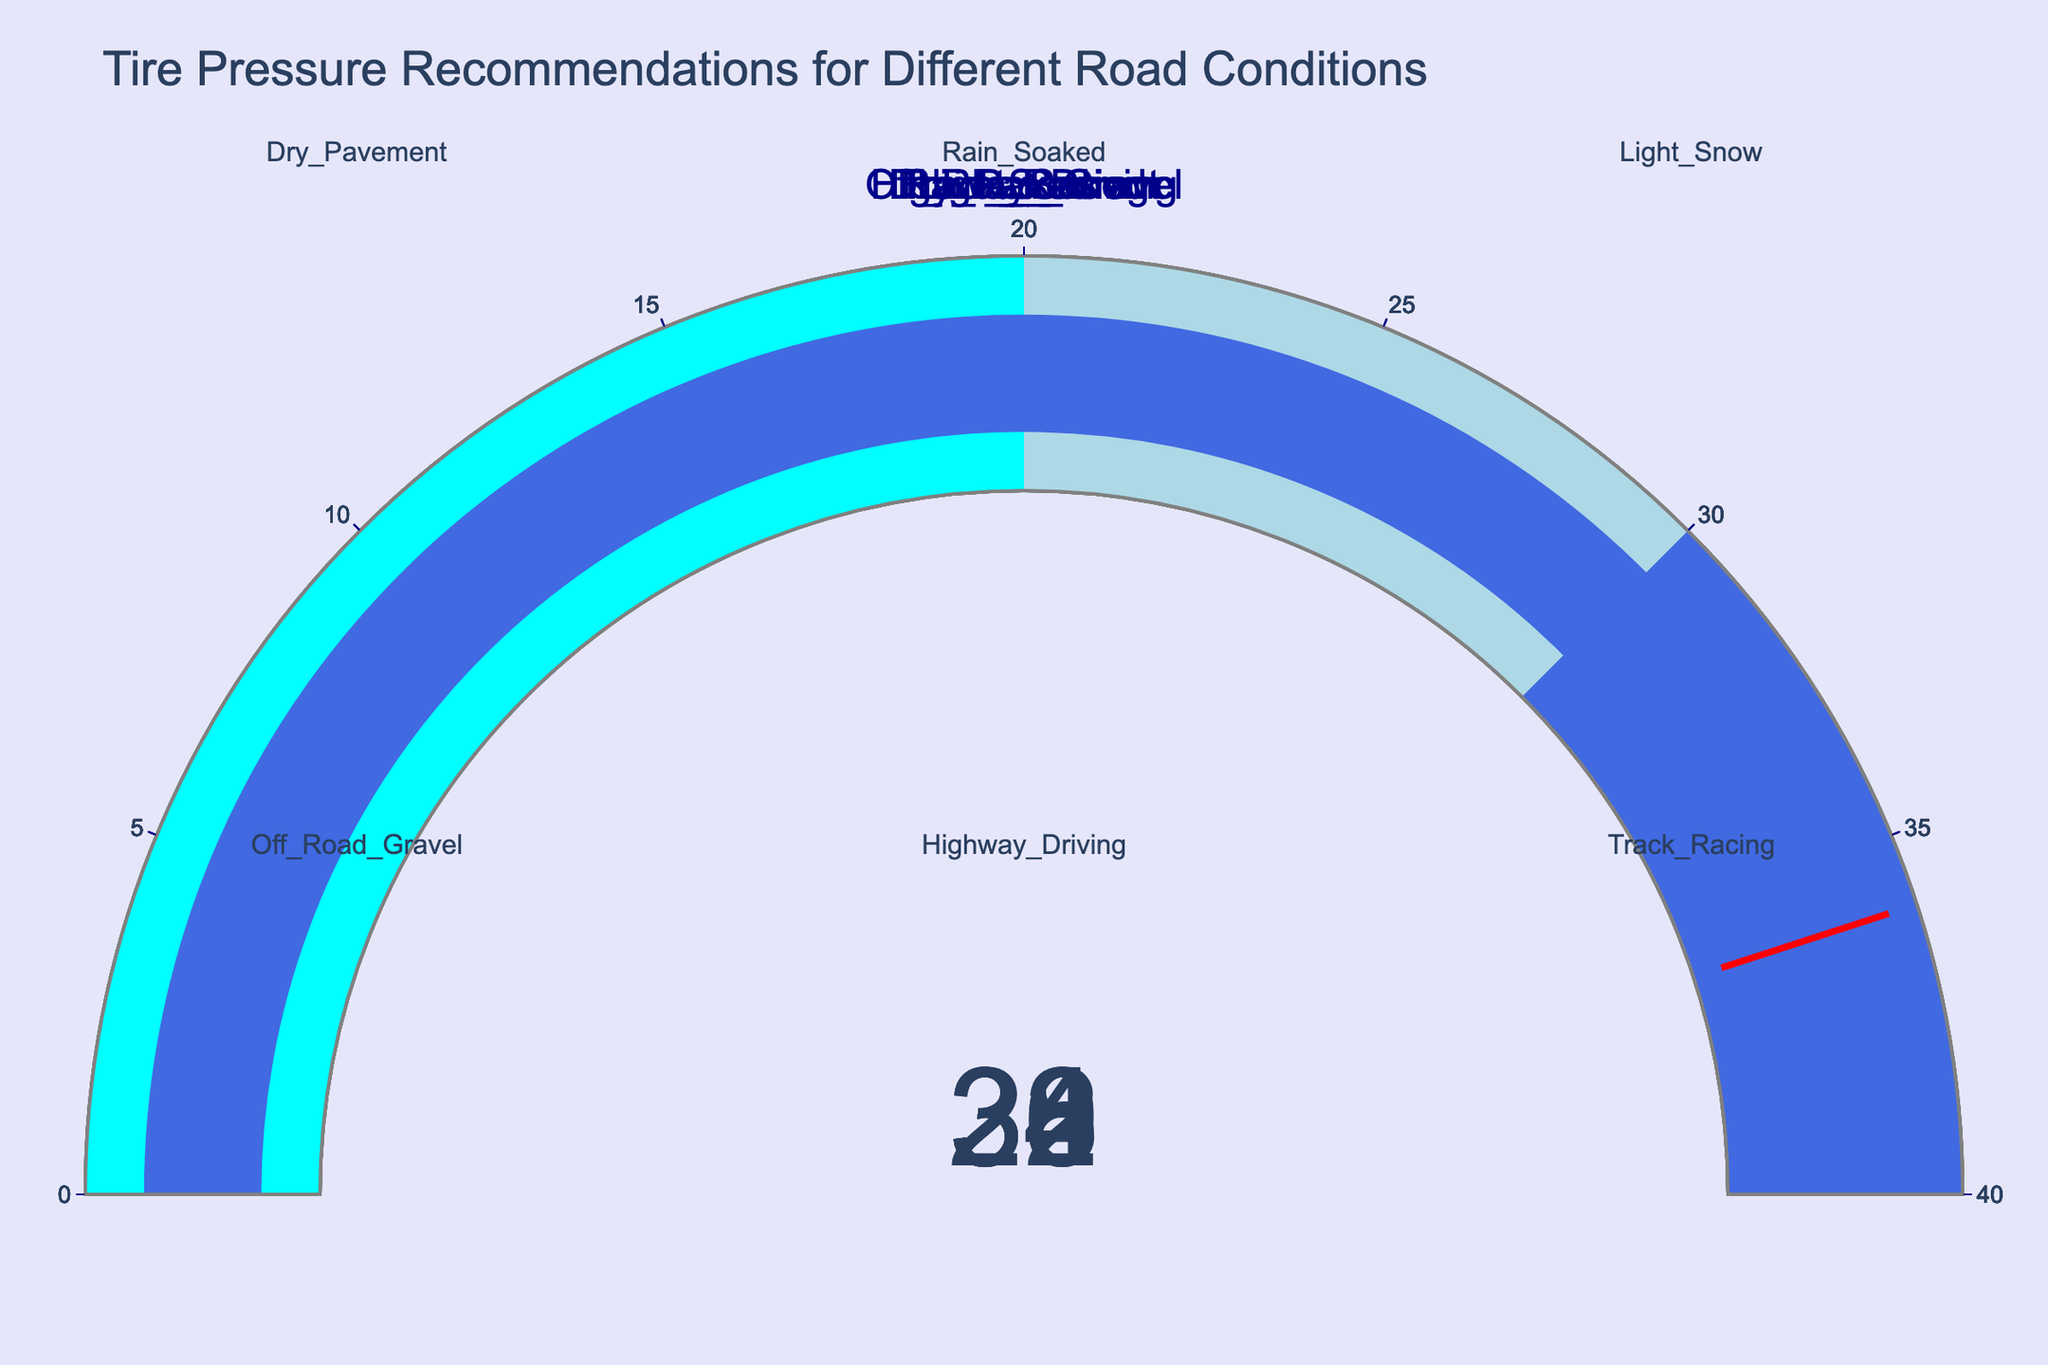What's the recommended tire pressure for Dry Pavement? The figure includes a gauge for each road condition. The gauge for Dry Pavement indicates a value of 32 PSI.
Answer: 32 PSI Which road condition has the highest recommended tire pressure? By looking at all gauges, Track Racing has the highest indicated value at 36 PSI.
Answer: Track Racing What is the difference in recommended tire pressure between Dry Pavement and Off-Road Gravel? The recommended tire pressure for Dry Pavement is 32 PSI and for Off-Road Gravel is 26 PSI. The difference is 32 - 26 = 6 PSI.
Answer: 6 PSI Are any road conditions recommended to have a tire pressure above 34 PSI? From examining the gauges, Track Racing is the only condition where the tire pressure exceeds 34 PSI with a value of 36 PSI.
Answer: Yes What is the average recommended tire pressure across all conditions? Summing all gauge values: 32 (Dry Pavement) + 30 (Rain Soaked) + 28 (Light Snow) + 26 (Off Road Gravel) + 34 (Highway Driving) + 36 (Track Racing) = 186 PSI. Dividing by the number of conditions (6), the average is 186 / 6 = 31 PSI.
Answer: 31 PSI Which two road conditions have less than 30 PSI recommended tire pressure? The gauges for Light Snow and Off-Road Gravel show pressures of 28 PSI and 26 PSI respectively, both less than 30 PSI.
Answer: Light Snow and Off-Road Gravel What color are the gauges for tire pressures in the range of 30-40 PSI? The background color for the gauge segments in the range of 30-40 PSI is royal blue.
Answer: Royal blue Which recommended tire pressure is closest to the average value of all road conditions? The average tire pressure is 31 PSI. The closest gauge value to 31 is 30 PSI for Rain Soaked conditions.
Answer: Rain Soaked How many road conditions recommend a tire pressure of 32 PSI or higher? Examining the figure, the conditions with 32 PSI or higher are Dry Pavement, Highway Driving, and Track Racing, totaling 3 conditions.
Answer: 3 What is the visual threshold indicator line color for all the conditions? The threshold line on each gauge is colored red.
Answer: Red 